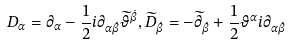Convert formula to latex. <formula><loc_0><loc_0><loc_500><loc_500>D _ { \alpha } = \partial _ { \alpha } - \frac { 1 } { 2 } i \partial _ { \alpha \dot { \beta } } \widetilde { \vartheta } ^ { \dot { \beta } } , \widetilde { D } _ { \dot { \beta } } = - \widetilde { \partial } _ { \dot { \beta } } + \frac { 1 } { 2 } \vartheta ^ { \alpha } i \partial _ { \alpha \dot { \beta } }</formula> 